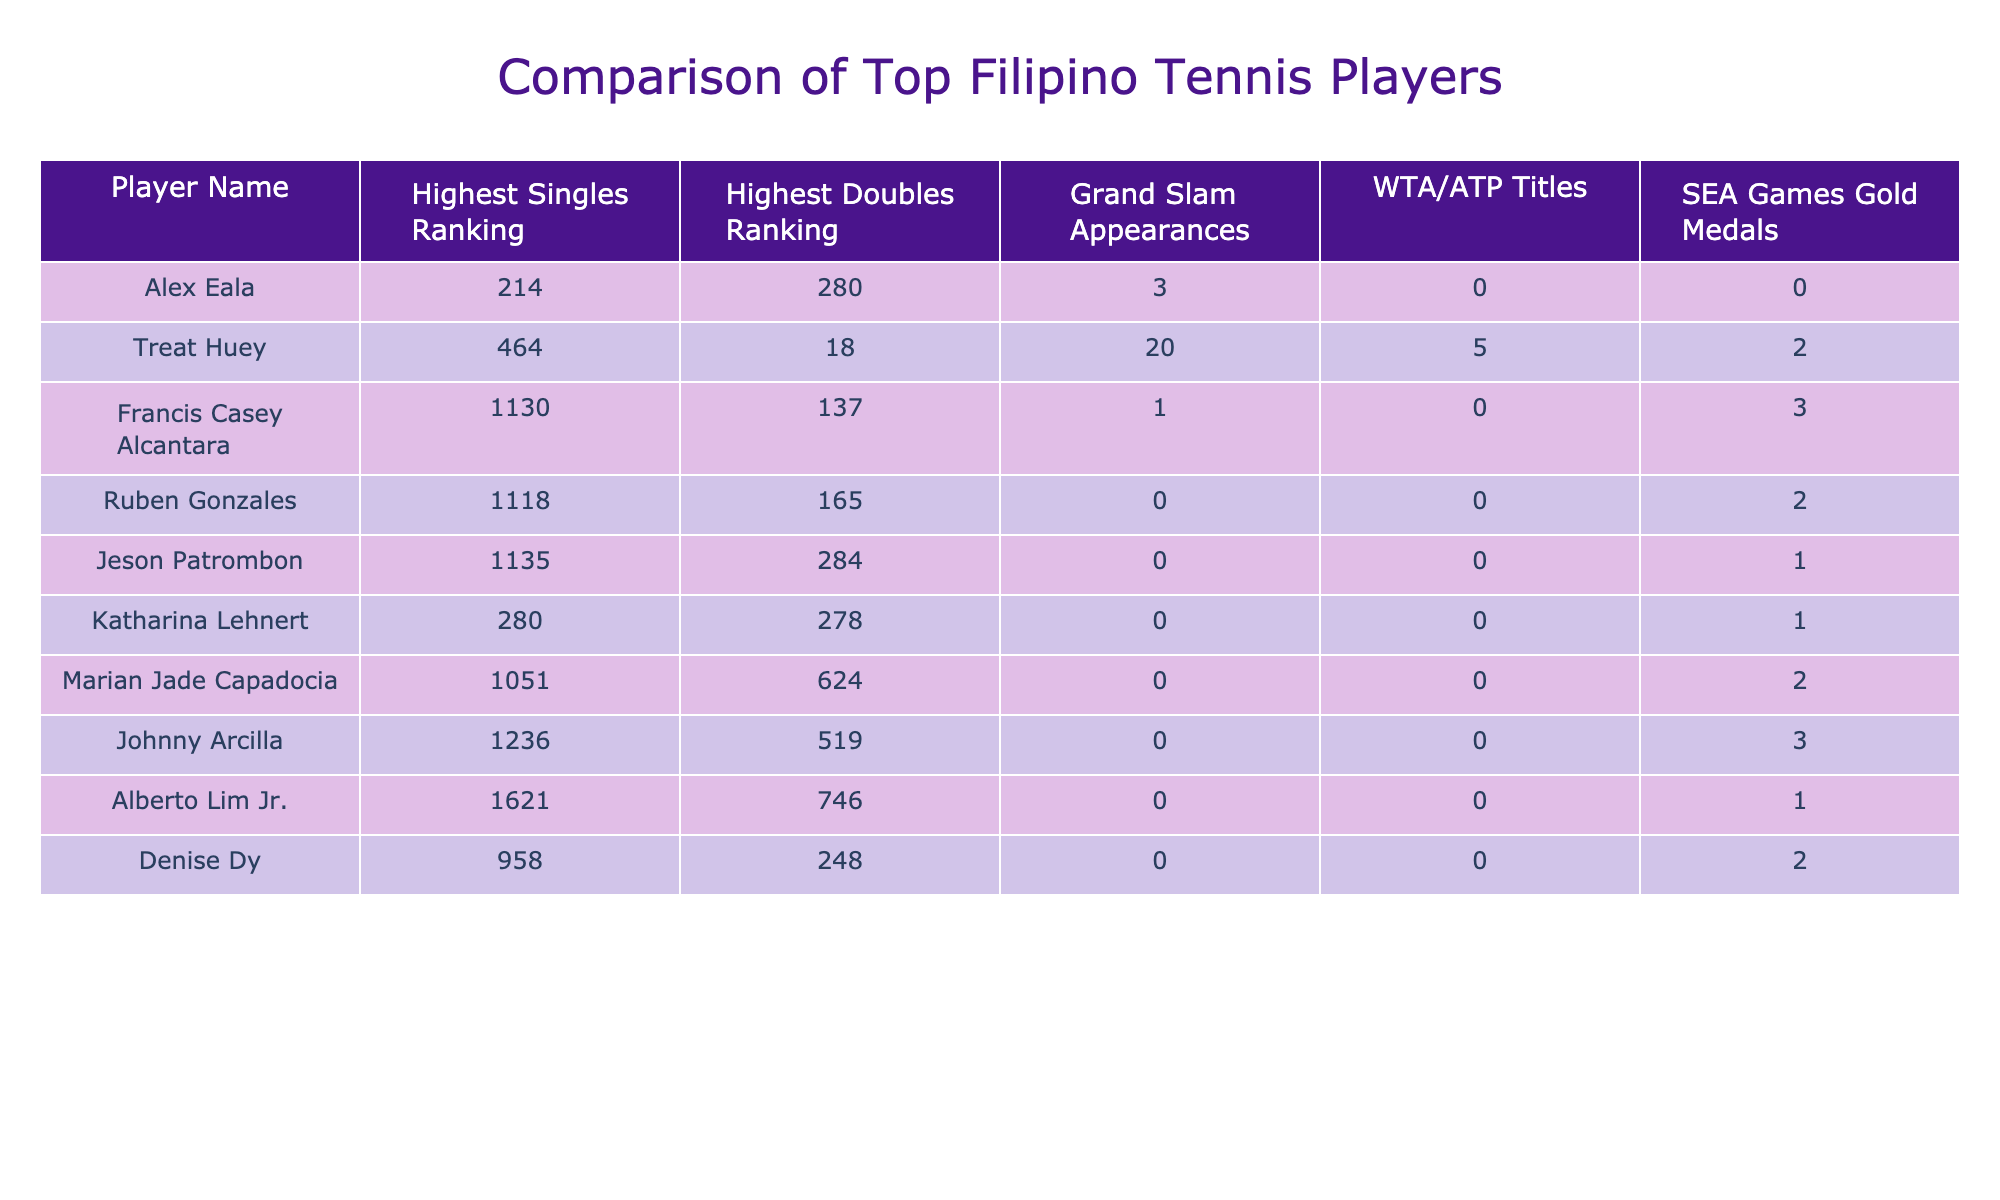What is the highest singles ranking achieved by Alex Eala? According to the table, Alex Eala's highest singles ranking is listed as 214.
Answer: 214 How many Grand Slam appearances has Treat Huey made? The table shows that Treat Huey has made 20 Grand Slam appearances.
Answer: 20 Who has the highest doubles ranking among the players listed? The player with the highest doubles ranking in the table is Treat Huey, with a ranking of 18.
Answer: Treat Huey What is the total number of WTA/ATP titles won by all the players combined? Adding the titles up: 0 (Alex Eala) + 5 (Treat Huey) + 0 (Francis Casey Alcantara) + 0 (Ruben Gonzales) + 0 (Jeson Patrombon) + 0 (Katharina Lehnert) + 0 (Marian Jade Capadocia) + 0 (Johnny Arcilla) + 0 (Alberto Lim Jr.) + 0 (Denise Dy) = 5 titles total.
Answer: 5 Is it true that Ruben Gonzales has competed in any Grand Slam tournaments? The table indicates that Ruben Gonzales has 0 Grand Slam appearances, which means he has not competed in any.
Answer: No Which player has won the most SEA Games gold medals? By checking the SEA Games gold medals column, Treat Huey has the most with 2 medals.
Answer: Treat Huey What is the difference in highest singles ranking between Francis Casey Alcantara and Marian Jade Capadocia? The highest singles rankings are 1130 (Francis Casey Alcantara) and 1051 (Marian Jade Capadocia). The difference is 1130 - 1051 = 79.
Answer: 79 How many players have achieved a highest singles ranking above 1000? The players with highest singles rankings above 1000 are Francis Casey Alcantara (1130), Ruben Gonzales (1118), Jeson Patrombon (1135), Marian Jade Capadocia (1051), and Johnny Arcilla (1236), totaling 5 players.
Answer: 5 If we consider only those players who have both WTA/ATP titles and SEA Games gold medals, would any player fit that criteria? The players who have titles are Treat Huey (5 titles, 2 golds) while the others do not have titles. Hence, Treat Huey fits the criteria.
Answer: Yes Which players have not won any SEA Games gold medals? By looking at the table, Alex Eala, Francis Casey Alcantara, Ruben Gonzales, Jeson Patrombon, Katharina Lehnert, Marian Jade Capadocia, Johnny Arcilla, Alberto Lim Jr., and Denise Dy fall into this category since they all have 0 gold medals.
Answer: Alex Eala, Francis Casey Alcantara, Ruben Gonzales, Jeson Patrombon, Katharina Lehnert, Marian Jade Capadocia, Johnny Arcilla, Alberto Lim Jr., Denise Dy 